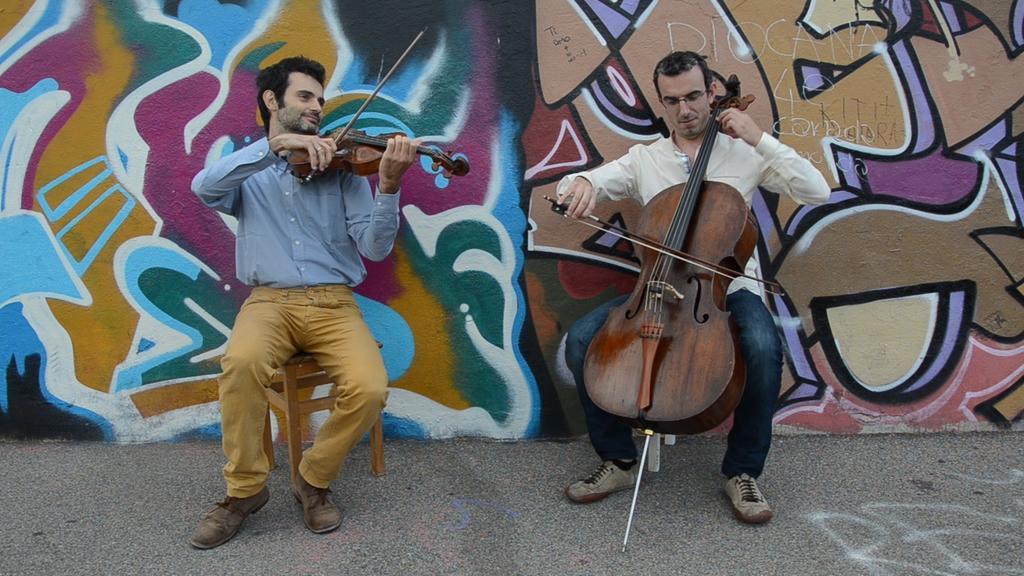Can you describe this image briefly? This image is clicked on the roads. There are two men in this image. Both are playing violin. To the left, the man is wearing blue shirt. To the right, the man is wearing white shirt. In the background, on the wall there is a graffiti. At the bottom, there is road. 